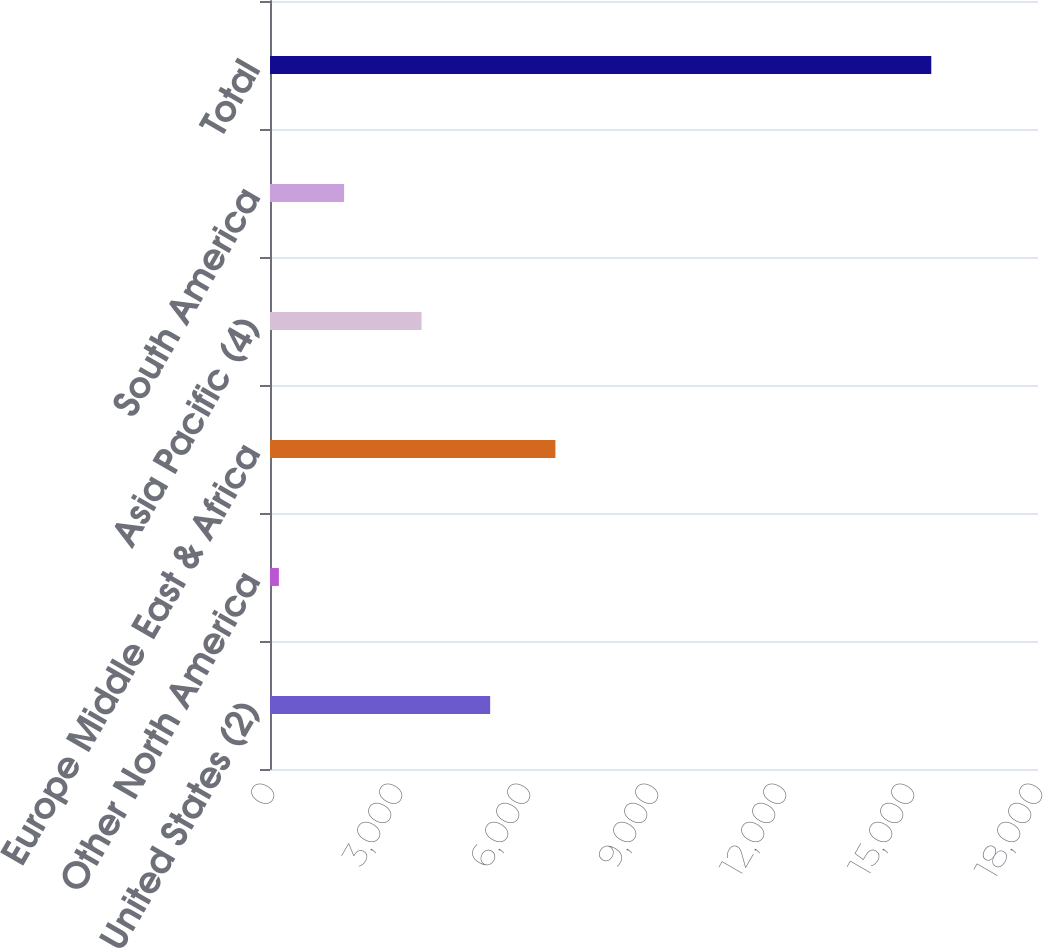Convert chart to OTSL. <chart><loc_0><loc_0><loc_500><loc_500><bar_chart><fcel>United States (2)<fcel>Other North America<fcel>Europe Middle East & Africa<fcel>Asia Pacific (4)<fcel>South America<fcel>Total<nl><fcel>5160<fcel>208<fcel>6689.1<fcel>3552<fcel>1737.1<fcel>15499<nl></chart> 